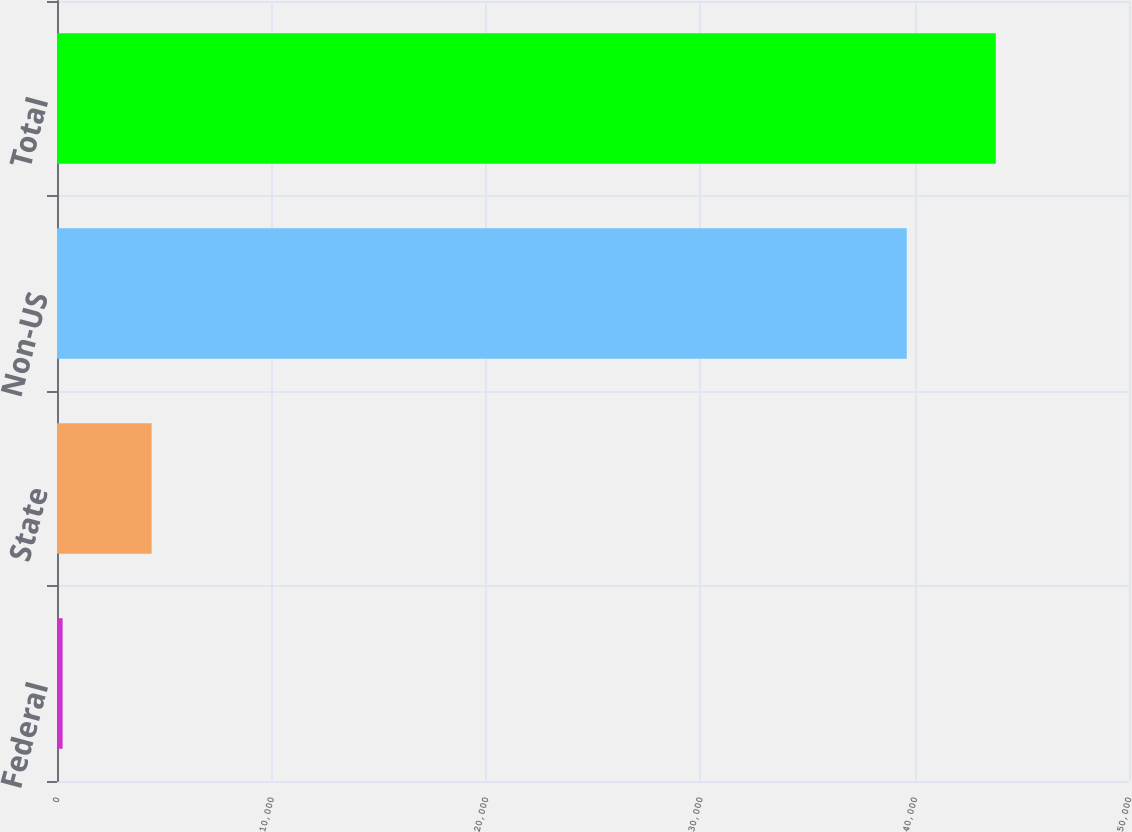Convert chart to OTSL. <chart><loc_0><loc_0><loc_500><loc_500><bar_chart><fcel>Federal<fcel>State<fcel>Non-US<fcel>Total<nl><fcel>262<fcel>4414.6<fcel>39634<fcel>43786.6<nl></chart> 